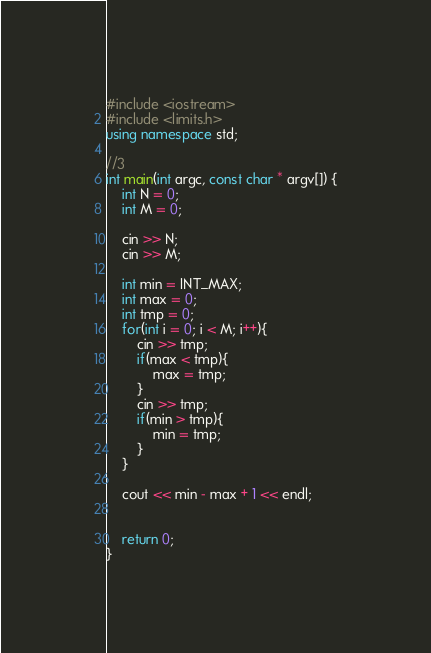Convert code to text. <code><loc_0><loc_0><loc_500><loc_500><_C++_>#include <iostream>
#include <limits.h>
using namespace std;

//3
int main(int argc, const char * argv[]) {
    int N = 0;
    int M = 0;
    
    cin >> N;
    cin >> M;

    int min = INT_MAX;
    int max = 0;
    int tmp = 0;
    for(int i = 0; i < M; i++){
        cin >> tmp;
        if(max < tmp){
            max = tmp;
        }
        cin >> tmp;
        if(min > tmp){
            min = tmp;
        }
    }

    cout << min - max + 1 << endl;


    return 0;
}
</code> 